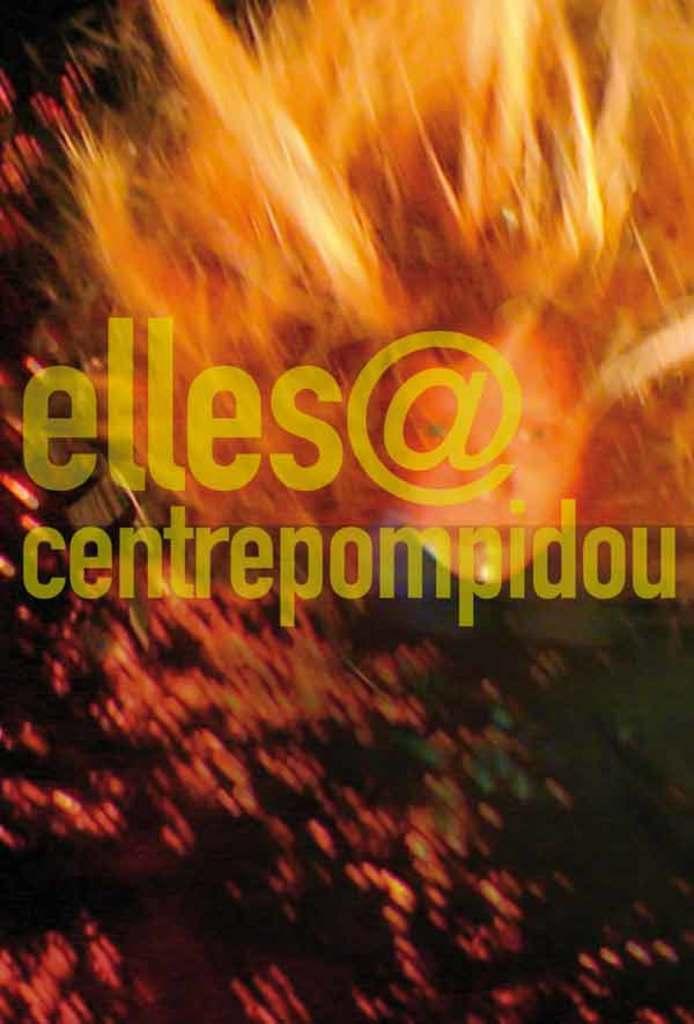Could you give a brief overview of what you see in this image? This is an edited image, in this image there is fire, in the middle there is some text. 